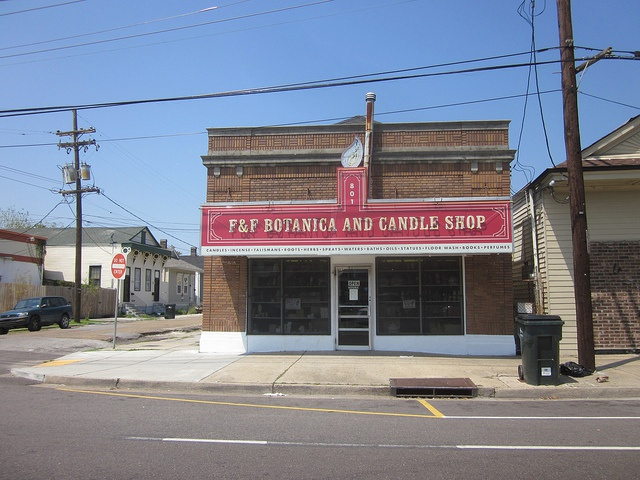Describe the objects in this image and their specific colors. I can see a car in blue, black, and gray tones in this image. 